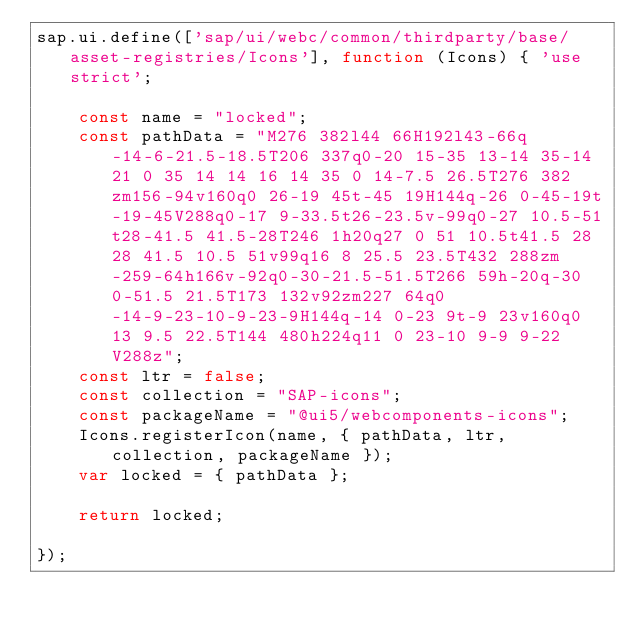<code> <loc_0><loc_0><loc_500><loc_500><_JavaScript_>sap.ui.define(['sap/ui/webc/common/thirdparty/base/asset-registries/Icons'], function (Icons) { 'use strict';

	const name = "locked";
	const pathData = "M276 382l44 66H192l43-66q-14-6-21.5-18.5T206 337q0-20 15-35 13-14 35-14 21 0 35 14 14 16 14 35 0 14-7.5 26.5T276 382zm156-94v160q0 26-19 45t-45 19H144q-26 0-45-19t-19-45V288q0-17 9-33.5t26-23.5v-99q0-27 10.5-51t28-41.5 41.5-28T246 1h20q27 0 51 10.5t41.5 28 28 41.5 10.5 51v99q16 8 25.5 23.5T432 288zm-259-64h166v-92q0-30-21.5-51.5T266 59h-20q-30 0-51.5 21.5T173 132v92zm227 64q0-14-9-23-10-9-23-9H144q-14 0-23 9t-9 23v160q0 13 9.5 22.5T144 480h224q11 0 23-10 9-9 9-22V288z";
	const ltr = false;
	const collection = "SAP-icons";
	const packageName = "@ui5/webcomponents-icons";
	Icons.registerIcon(name, { pathData, ltr, collection, packageName });
	var locked = { pathData };

	return locked;

});
</code> 